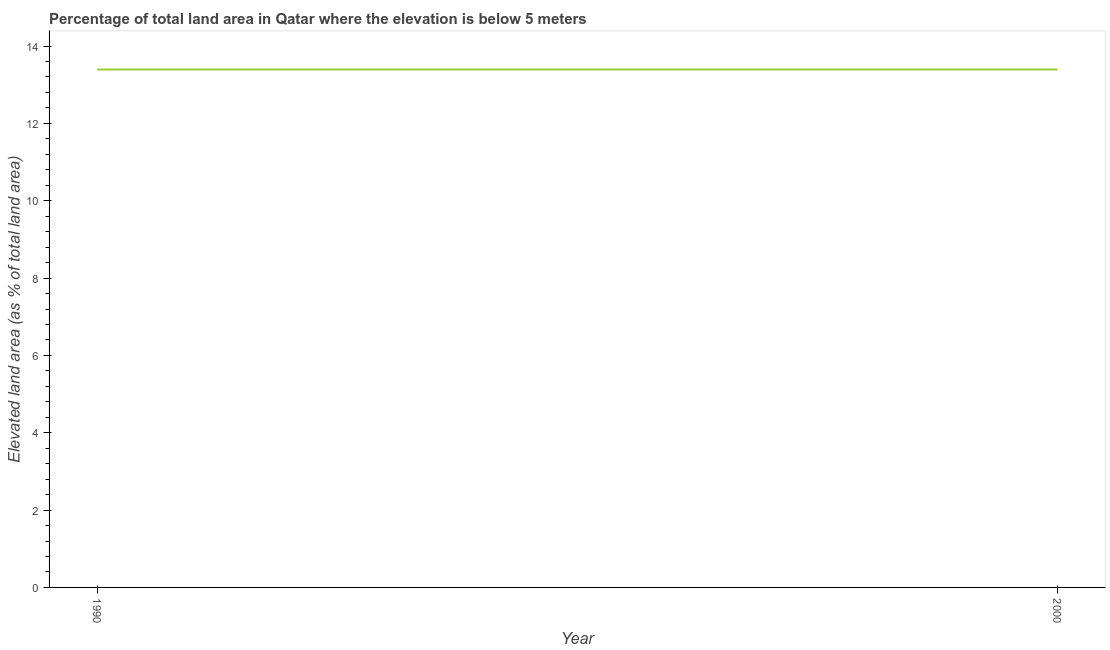What is the total elevated land area in 1990?
Provide a succinct answer. 13.39. Across all years, what is the maximum total elevated land area?
Ensure brevity in your answer.  13.39. Across all years, what is the minimum total elevated land area?
Offer a terse response. 13.39. What is the sum of the total elevated land area?
Your answer should be compact. 26.79. What is the average total elevated land area per year?
Your answer should be compact. 13.39. What is the median total elevated land area?
Your response must be concise. 13.39. Is the total elevated land area in 1990 less than that in 2000?
Ensure brevity in your answer.  No. In how many years, is the total elevated land area greater than the average total elevated land area taken over all years?
Give a very brief answer. 0. Does the total elevated land area monotonically increase over the years?
Offer a terse response. No. What is the difference between two consecutive major ticks on the Y-axis?
Ensure brevity in your answer.  2. Are the values on the major ticks of Y-axis written in scientific E-notation?
Make the answer very short. No. What is the title of the graph?
Your response must be concise. Percentage of total land area in Qatar where the elevation is below 5 meters. What is the label or title of the Y-axis?
Provide a succinct answer. Elevated land area (as % of total land area). What is the Elevated land area (as % of total land area) of 1990?
Offer a very short reply. 13.39. What is the Elevated land area (as % of total land area) of 2000?
Ensure brevity in your answer.  13.39. What is the difference between the Elevated land area (as % of total land area) in 1990 and 2000?
Your response must be concise. 0. What is the ratio of the Elevated land area (as % of total land area) in 1990 to that in 2000?
Give a very brief answer. 1. 